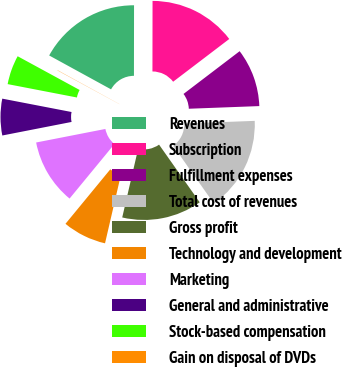<chart> <loc_0><loc_0><loc_500><loc_500><pie_chart><fcel>Revenues<fcel>Subscription<fcel>Fulfillment expenses<fcel>Total cost of revenues<fcel>Gross profit<fcel>Technology and development<fcel>Marketing<fcel>General and administrative<fcel>Stock-based compensation<fcel>Gain on disposal of DVDs<nl><fcel>17.05%<fcel>14.62%<fcel>9.76%<fcel>15.83%<fcel>13.4%<fcel>7.33%<fcel>10.97%<fcel>6.11%<fcel>4.9%<fcel>0.04%<nl></chart> 